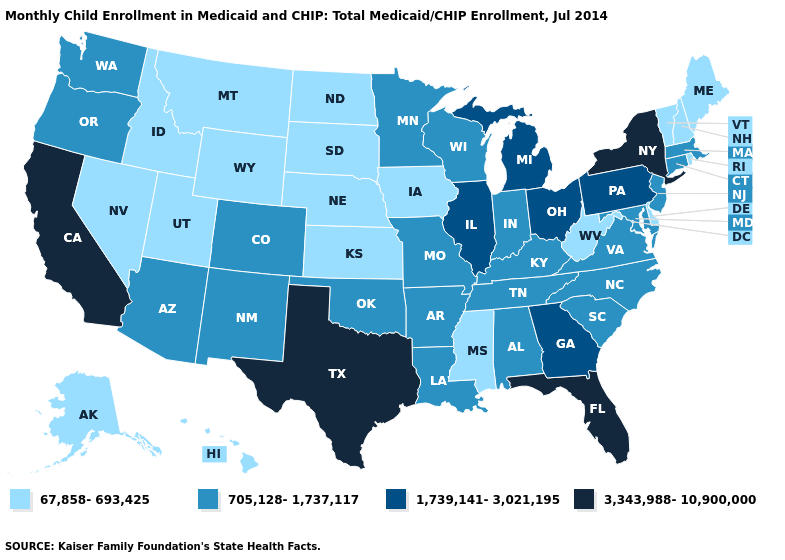What is the highest value in the Northeast ?
Keep it brief. 3,343,988-10,900,000. Does South Dakota have the lowest value in the USA?
Give a very brief answer. Yes. What is the highest value in the USA?
Be succinct. 3,343,988-10,900,000. Among the states that border Michigan , which have the highest value?
Quick response, please. Ohio. Among the states that border Indiana , does Kentucky have the highest value?
Answer briefly. No. What is the highest value in the MidWest ?
Keep it brief. 1,739,141-3,021,195. What is the value of Texas?
Short answer required. 3,343,988-10,900,000. Which states have the highest value in the USA?
Write a very short answer. California, Florida, New York, Texas. What is the lowest value in the USA?
Keep it brief. 67,858-693,425. Does the first symbol in the legend represent the smallest category?
Write a very short answer. Yes. How many symbols are there in the legend?
Quick response, please. 4. Name the states that have a value in the range 1,739,141-3,021,195?
Be succinct. Georgia, Illinois, Michigan, Ohio, Pennsylvania. Does Tennessee have the lowest value in the South?
Be succinct. No. What is the value of Texas?
Give a very brief answer. 3,343,988-10,900,000. 